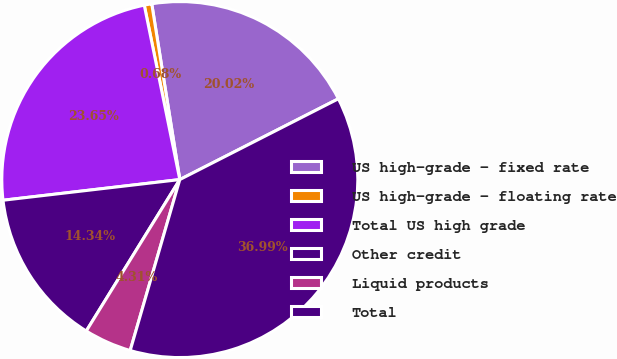Convert chart to OTSL. <chart><loc_0><loc_0><loc_500><loc_500><pie_chart><fcel>US high-grade - fixed rate<fcel>US high-grade - floating rate<fcel>Total US high grade<fcel>Other credit<fcel>Liquid products<fcel>Total<nl><fcel>20.02%<fcel>0.68%<fcel>23.65%<fcel>14.34%<fcel>4.31%<fcel>36.99%<nl></chart> 